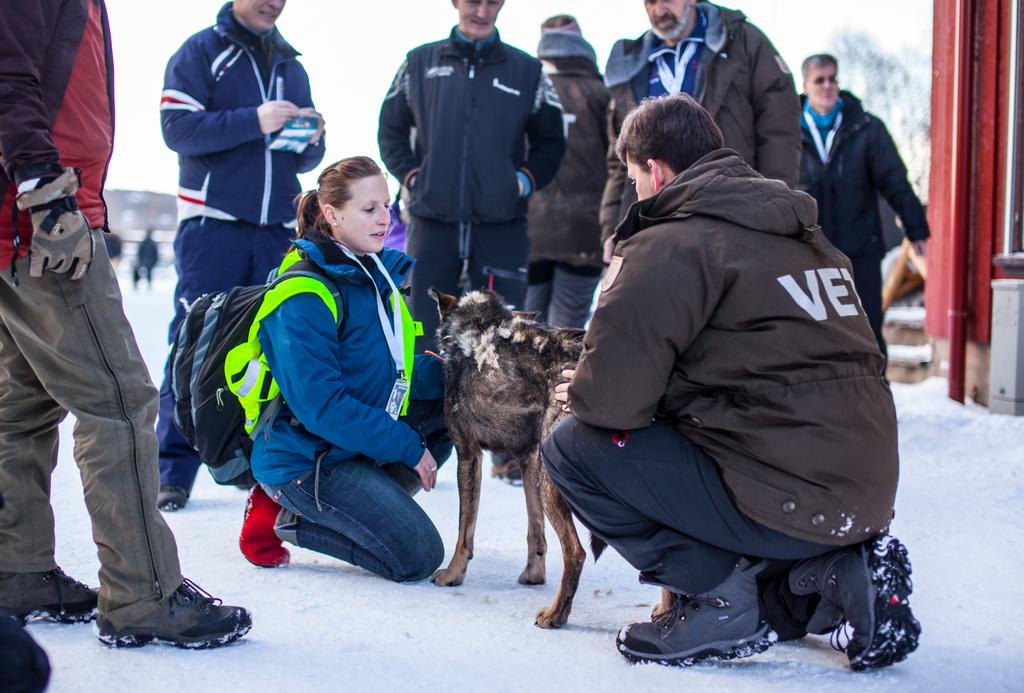How many people are in the image? There is a group of people in the image. What are the people in the image doing? Some people are seated on the ground, while others are standing. What animal is present in the image? There is a dog in the image. Where are the people and the dog located in the image? All the people and the dog are in the ice. Can you see any snakes wearing a crown in the image? There are no snakes or crowns present in the image; it features a group of people and a dog in the ice. 